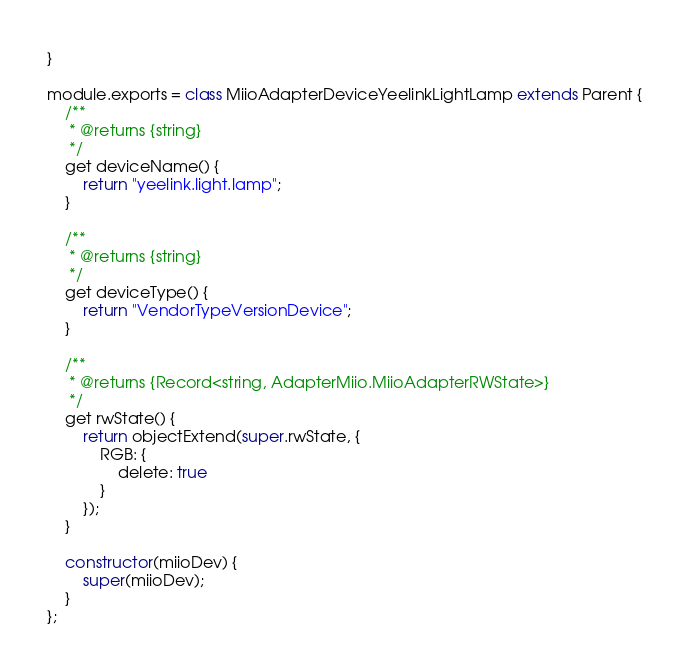Convert code to text. <code><loc_0><loc_0><loc_500><loc_500><_JavaScript_>}

module.exports = class MiioAdapterDeviceYeelinkLightLamp extends Parent {
    /**
     * @returns {string}
     */
    get deviceName() {
        return "yeelink.light.lamp";
    }

    /**
     * @returns {string}
     */
    get deviceType() {
        return "VendorTypeVersionDevice";
    }

    /**
     * @returns {Record<string, AdapterMiio.MiioAdapterRWState>}
     */
    get rwState() {
        return objectExtend(super.rwState, {
            RGB: {
                delete: true
            }
        });
    }

    constructor(miioDev) {
        super(miioDev);
    }
};</code> 